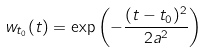Convert formula to latex. <formula><loc_0><loc_0><loc_500><loc_500>w _ { t _ { 0 } } ( t ) = \exp \left ( - \frac { ( t - t _ { 0 } ) ^ { 2 } } { 2 a ^ { 2 } } \right )</formula> 